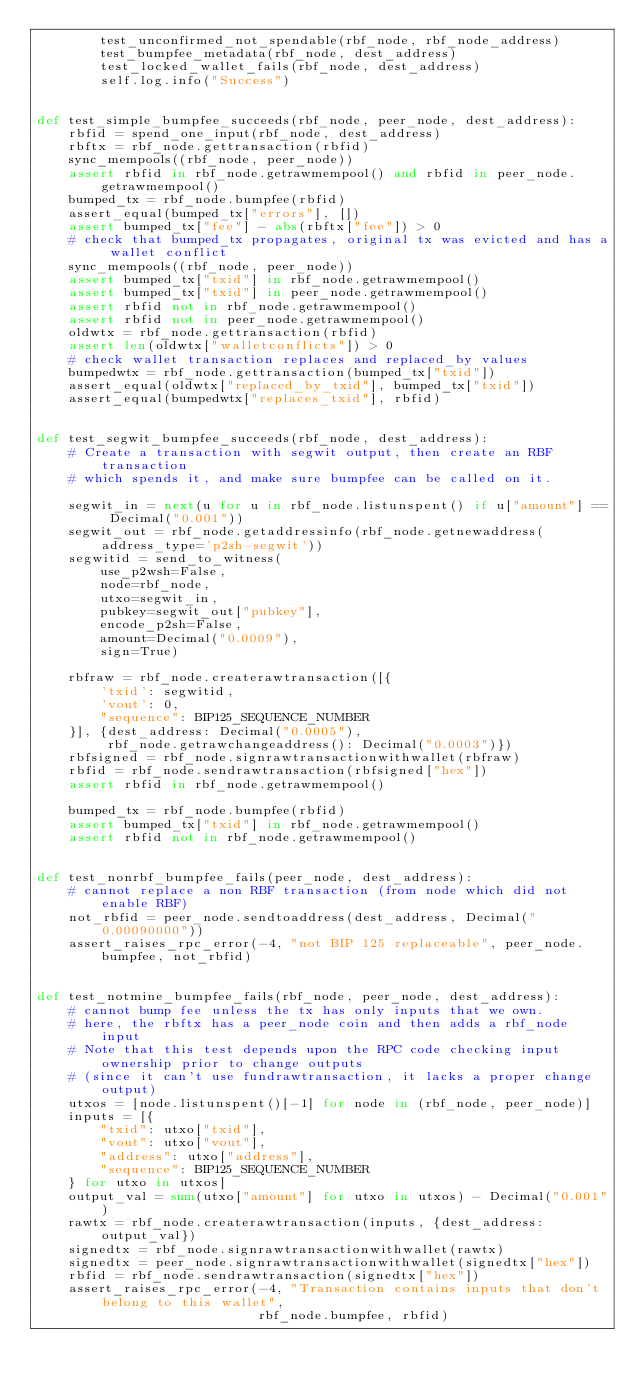<code> <loc_0><loc_0><loc_500><loc_500><_Python_>        test_unconfirmed_not_spendable(rbf_node, rbf_node_address)
        test_bumpfee_metadata(rbf_node, dest_address)
        test_locked_wallet_fails(rbf_node, dest_address)
        self.log.info("Success")


def test_simple_bumpfee_succeeds(rbf_node, peer_node, dest_address):
    rbfid = spend_one_input(rbf_node, dest_address)
    rbftx = rbf_node.gettransaction(rbfid)
    sync_mempools((rbf_node, peer_node))
    assert rbfid in rbf_node.getrawmempool() and rbfid in peer_node.getrawmempool()
    bumped_tx = rbf_node.bumpfee(rbfid)
    assert_equal(bumped_tx["errors"], [])
    assert bumped_tx["fee"] - abs(rbftx["fee"]) > 0
    # check that bumped_tx propagates, original tx was evicted and has a wallet conflict
    sync_mempools((rbf_node, peer_node))
    assert bumped_tx["txid"] in rbf_node.getrawmempool()
    assert bumped_tx["txid"] in peer_node.getrawmempool()
    assert rbfid not in rbf_node.getrawmempool()
    assert rbfid not in peer_node.getrawmempool()
    oldwtx = rbf_node.gettransaction(rbfid)
    assert len(oldwtx["walletconflicts"]) > 0
    # check wallet transaction replaces and replaced_by values
    bumpedwtx = rbf_node.gettransaction(bumped_tx["txid"])
    assert_equal(oldwtx["replaced_by_txid"], bumped_tx["txid"])
    assert_equal(bumpedwtx["replaces_txid"], rbfid)


def test_segwit_bumpfee_succeeds(rbf_node, dest_address):
    # Create a transaction with segwit output, then create an RBF transaction
    # which spends it, and make sure bumpfee can be called on it.

    segwit_in = next(u for u in rbf_node.listunspent() if u["amount"] == Decimal("0.001"))
    segwit_out = rbf_node.getaddressinfo(rbf_node.getnewaddress(address_type='p2sh-segwit'))
    segwitid = send_to_witness(
        use_p2wsh=False,
        node=rbf_node,
        utxo=segwit_in,
        pubkey=segwit_out["pubkey"],
        encode_p2sh=False,
        amount=Decimal("0.0009"),
        sign=True)

    rbfraw = rbf_node.createrawtransaction([{
        'txid': segwitid,
        'vout': 0,
        "sequence": BIP125_SEQUENCE_NUMBER
    }], {dest_address: Decimal("0.0005"),
         rbf_node.getrawchangeaddress(): Decimal("0.0003")})
    rbfsigned = rbf_node.signrawtransactionwithwallet(rbfraw)
    rbfid = rbf_node.sendrawtransaction(rbfsigned["hex"])
    assert rbfid in rbf_node.getrawmempool()

    bumped_tx = rbf_node.bumpfee(rbfid)
    assert bumped_tx["txid"] in rbf_node.getrawmempool()
    assert rbfid not in rbf_node.getrawmempool()


def test_nonrbf_bumpfee_fails(peer_node, dest_address):
    # cannot replace a non RBF transaction (from node which did not enable RBF)
    not_rbfid = peer_node.sendtoaddress(dest_address, Decimal("0.00090000"))
    assert_raises_rpc_error(-4, "not BIP 125 replaceable", peer_node.bumpfee, not_rbfid)


def test_notmine_bumpfee_fails(rbf_node, peer_node, dest_address):
    # cannot bump fee unless the tx has only inputs that we own.
    # here, the rbftx has a peer_node coin and then adds a rbf_node input
    # Note that this test depends upon the RPC code checking input ownership prior to change outputs
    # (since it can't use fundrawtransaction, it lacks a proper change output)
    utxos = [node.listunspent()[-1] for node in (rbf_node, peer_node)]
    inputs = [{
        "txid": utxo["txid"],
        "vout": utxo["vout"],
        "address": utxo["address"],
        "sequence": BIP125_SEQUENCE_NUMBER
    } for utxo in utxos]
    output_val = sum(utxo["amount"] for utxo in utxos) - Decimal("0.001")
    rawtx = rbf_node.createrawtransaction(inputs, {dest_address: output_val})
    signedtx = rbf_node.signrawtransactionwithwallet(rawtx)
    signedtx = peer_node.signrawtransactionwithwallet(signedtx["hex"])
    rbfid = rbf_node.sendrawtransaction(signedtx["hex"])
    assert_raises_rpc_error(-4, "Transaction contains inputs that don't belong to this wallet",
                            rbf_node.bumpfee, rbfid)

</code> 